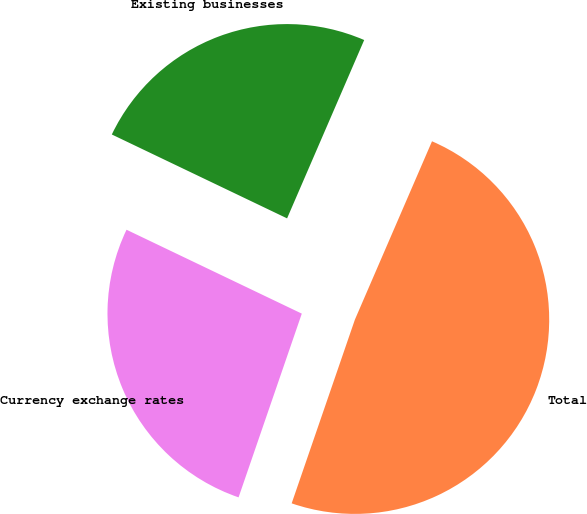Convert chart. <chart><loc_0><loc_0><loc_500><loc_500><pie_chart><fcel>Existing businesses<fcel>Currency exchange rates<fcel>Total<nl><fcel>24.39%<fcel>26.83%<fcel>48.78%<nl></chart> 